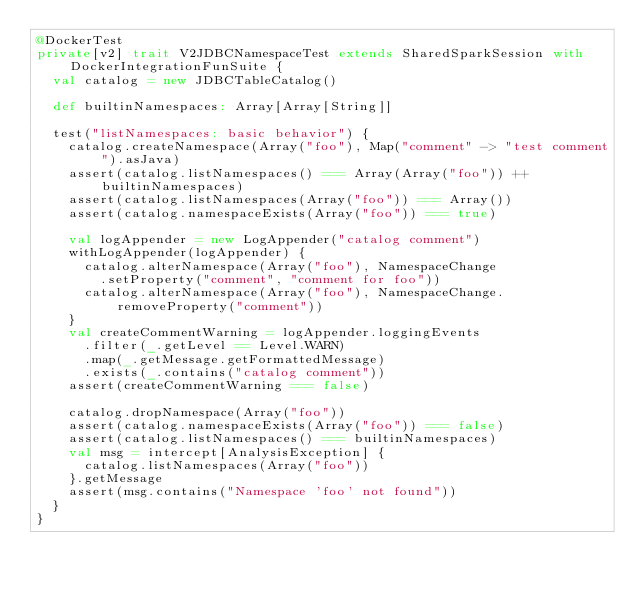Convert code to text. <code><loc_0><loc_0><loc_500><loc_500><_Scala_>@DockerTest
private[v2] trait V2JDBCNamespaceTest extends SharedSparkSession with DockerIntegrationFunSuite {
  val catalog = new JDBCTableCatalog()

  def builtinNamespaces: Array[Array[String]]

  test("listNamespaces: basic behavior") {
    catalog.createNamespace(Array("foo"), Map("comment" -> "test comment").asJava)
    assert(catalog.listNamespaces() === Array(Array("foo")) ++ builtinNamespaces)
    assert(catalog.listNamespaces(Array("foo")) === Array())
    assert(catalog.namespaceExists(Array("foo")) === true)

    val logAppender = new LogAppender("catalog comment")
    withLogAppender(logAppender) {
      catalog.alterNamespace(Array("foo"), NamespaceChange
        .setProperty("comment", "comment for foo"))
      catalog.alterNamespace(Array("foo"), NamespaceChange.removeProperty("comment"))
    }
    val createCommentWarning = logAppender.loggingEvents
      .filter(_.getLevel == Level.WARN)
      .map(_.getMessage.getFormattedMessage)
      .exists(_.contains("catalog comment"))
    assert(createCommentWarning === false)

    catalog.dropNamespace(Array("foo"))
    assert(catalog.namespaceExists(Array("foo")) === false)
    assert(catalog.listNamespaces() === builtinNamespaces)
    val msg = intercept[AnalysisException] {
      catalog.listNamespaces(Array("foo"))
    }.getMessage
    assert(msg.contains("Namespace 'foo' not found"))
  }
}
</code> 